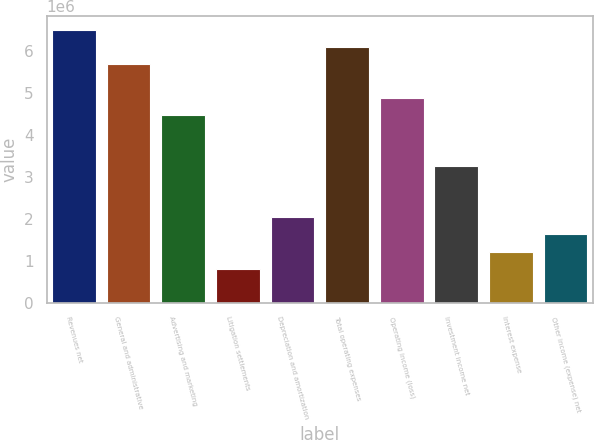<chart> <loc_0><loc_0><loc_500><loc_500><bar_chart><fcel>Revenues net<fcel>General and administrative<fcel>Advertising and marketing<fcel>Litigation settlements<fcel>Depreciation and amortization<fcel>Total operating expenses<fcel>Operating income (loss)<fcel>Investment income net<fcel>Interest expense<fcel>Other income (expense) net<nl><fcel>6.50815e+06<fcel>5.69464e+06<fcel>4.47436e+06<fcel>813526<fcel>2.0338e+06<fcel>6.10139e+06<fcel>4.88112e+06<fcel>3.25408e+06<fcel>1.22029e+06<fcel>1.62704e+06<nl></chart> 